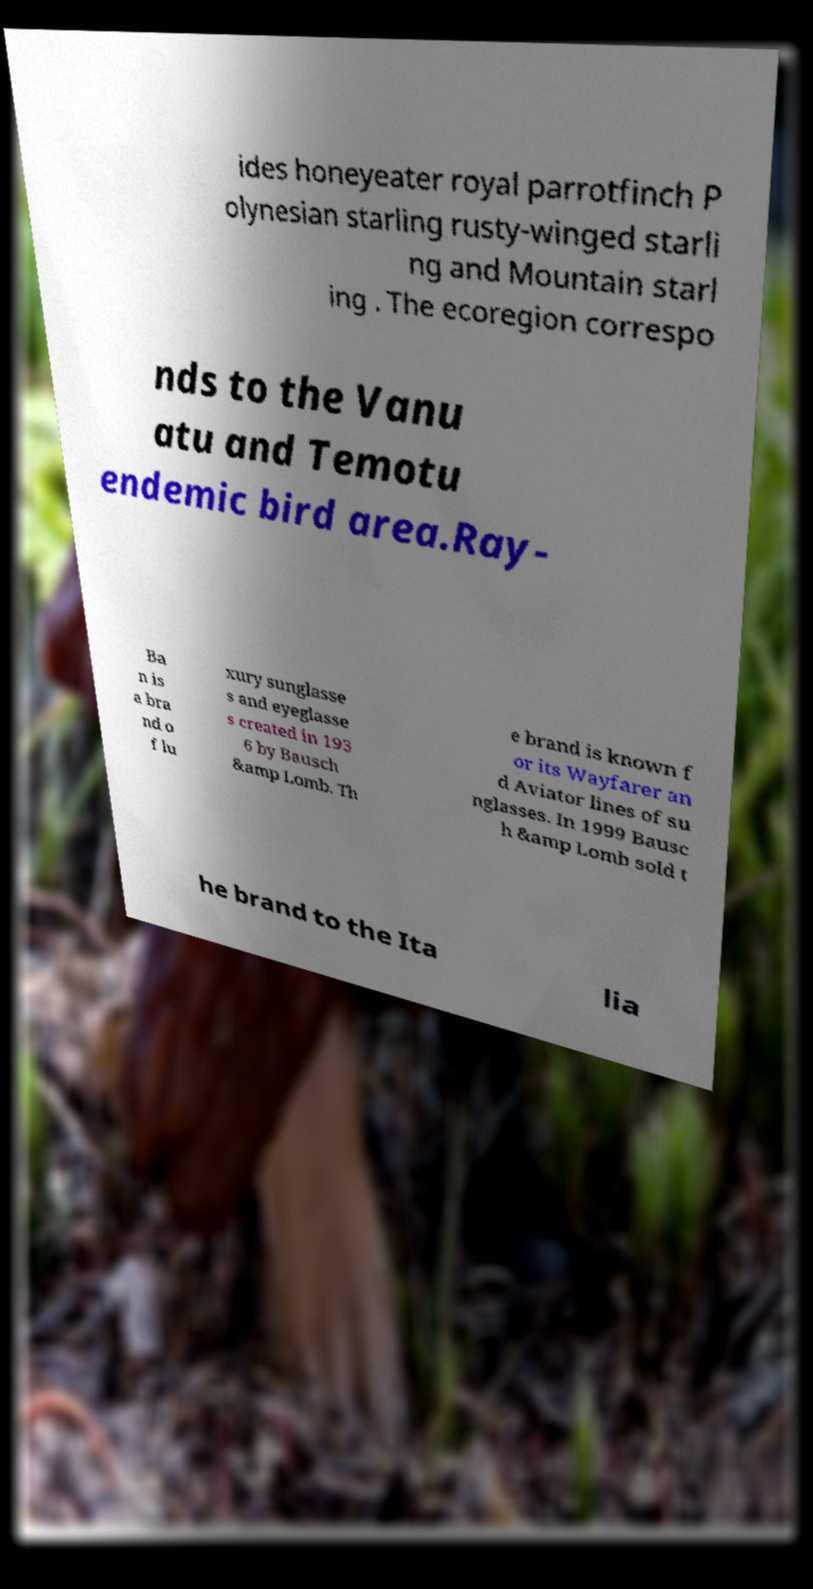There's text embedded in this image that I need extracted. Can you transcribe it verbatim? ides honeyeater royal parrotfinch P olynesian starling rusty-winged starli ng and Mountain starl ing . The ecoregion correspo nds to the Vanu atu and Temotu endemic bird area.Ray- Ba n is a bra nd o f lu xury sunglasse s and eyeglasse s created in 193 6 by Bausch &amp Lomb. Th e brand is known f or its Wayfarer an d Aviator lines of su nglasses. In 1999 Bausc h &amp Lomb sold t he brand to the Ita lia 